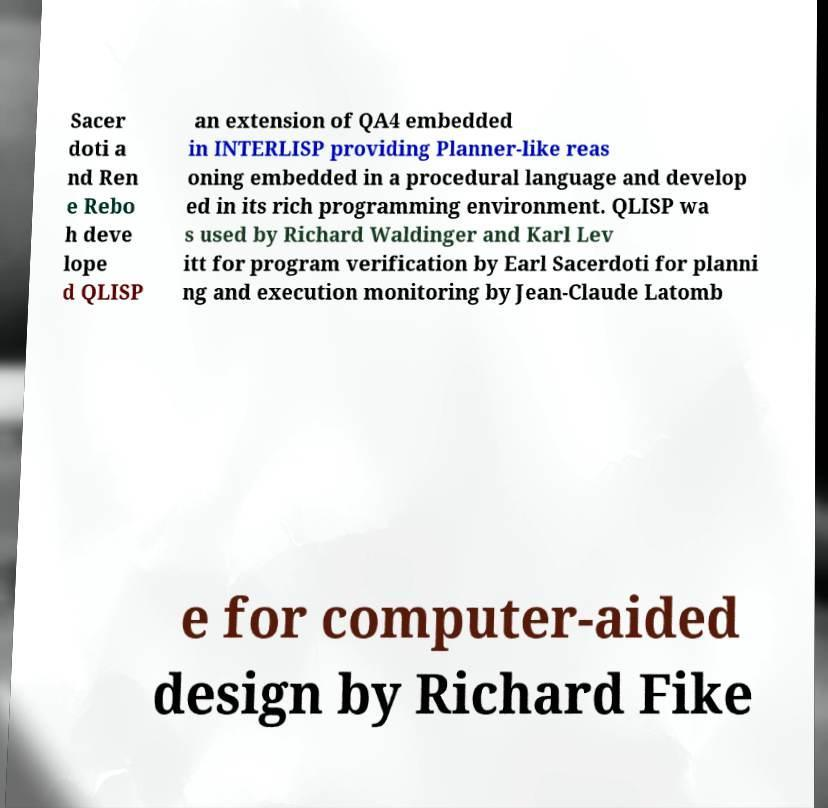There's text embedded in this image that I need extracted. Can you transcribe it verbatim? Sacer doti a nd Ren e Rebo h deve lope d QLISP an extension of QA4 embedded in INTERLISP providing Planner-like reas oning embedded in a procedural language and develop ed in its rich programming environment. QLISP wa s used by Richard Waldinger and Karl Lev itt for program verification by Earl Sacerdoti for planni ng and execution monitoring by Jean-Claude Latomb e for computer-aided design by Richard Fike 